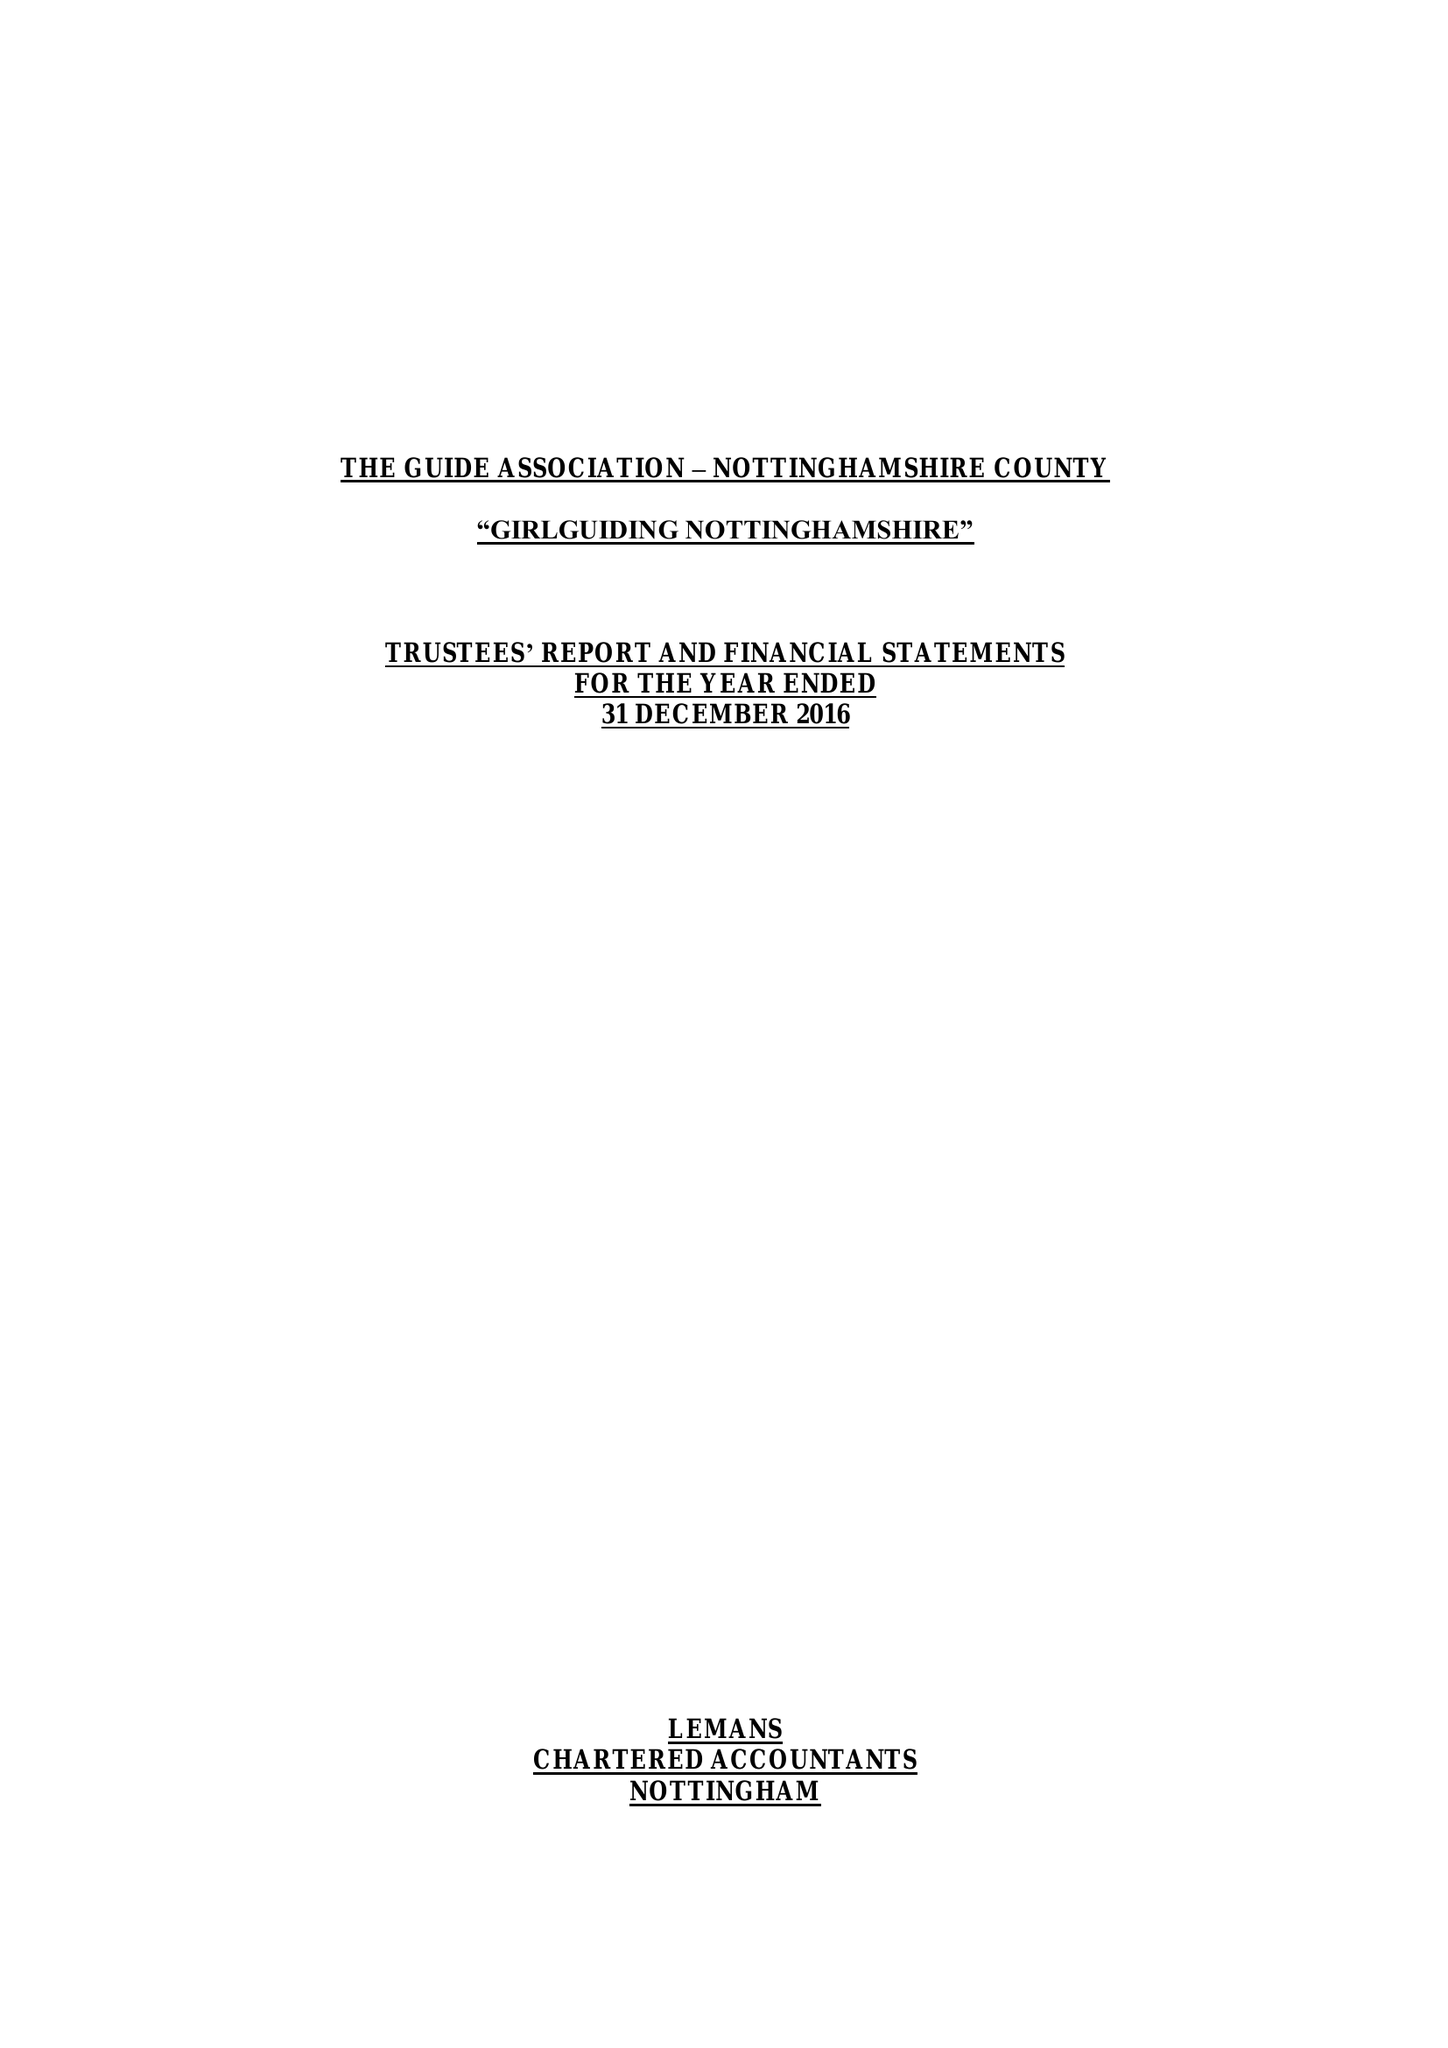What is the value for the address__post_town?
Answer the question using a single word or phrase. NOTTINGHAM 